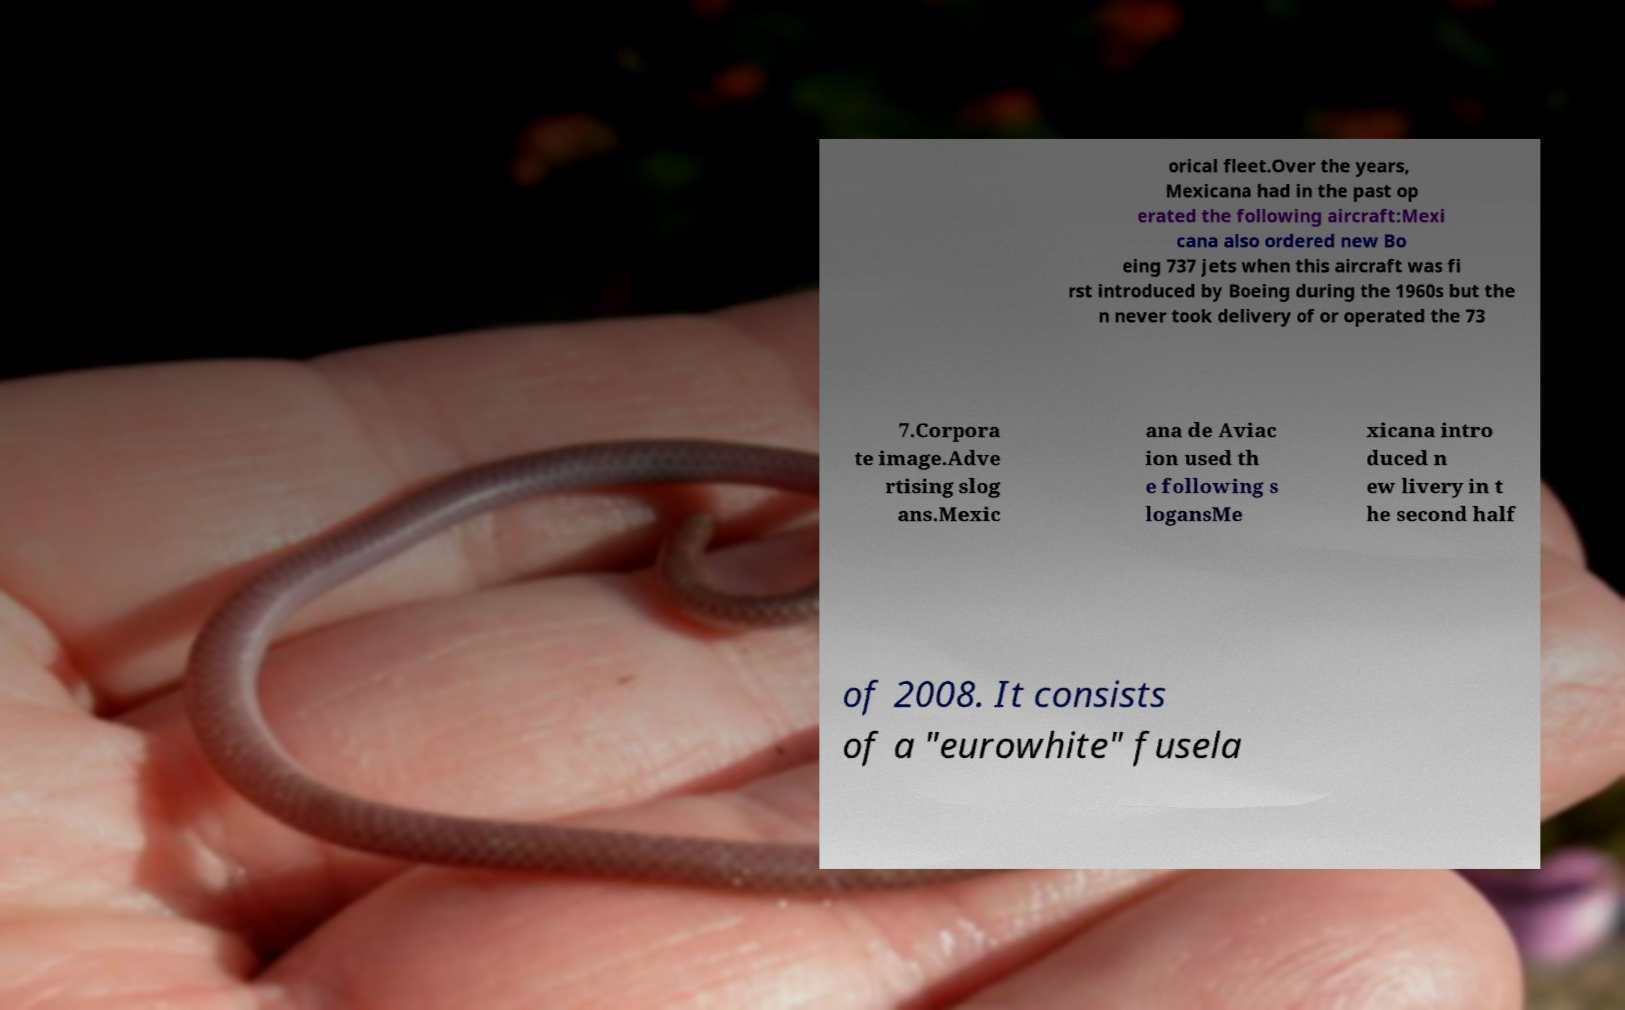Please read and relay the text visible in this image. What does it say? orical fleet.Over the years, Mexicana had in the past op erated the following aircraft:Mexi cana also ordered new Bo eing 737 jets when this aircraft was fi rst introduced by Boeing during the 1960s but the n never took delivery of or operated the 73 7.Corpora te image.Adve rtising slog ans.Mexic ana de Aviac ion used th e following s logansMe xicana intro duced n ew livery in t he second half of 2008. It consists of a "eurowhite" fusela 